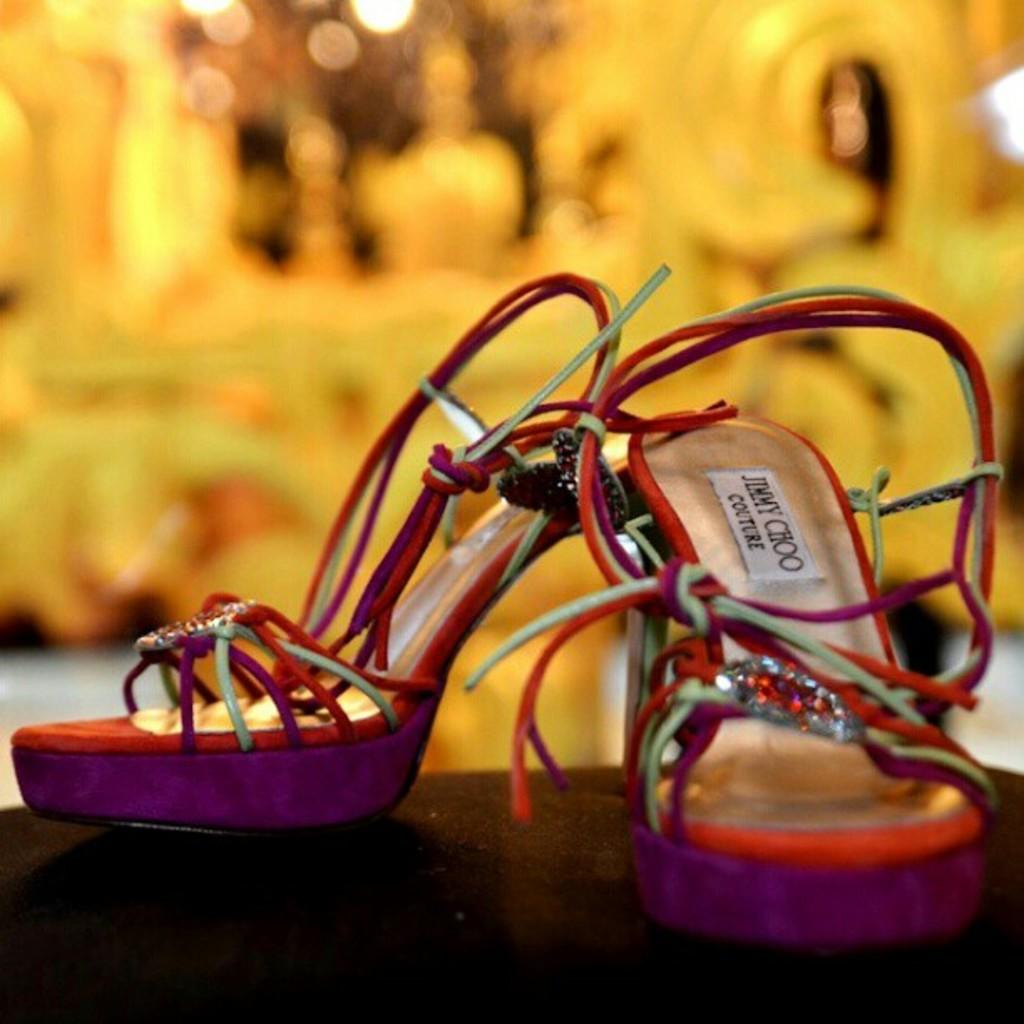What type of footwear is featured in the image? There are heels in the image. Can you describe the background of the image? The background of the image is blurry. How much attention does the structure in the image receive? There is no structure present in the image; it only features heels and a blurry background. 